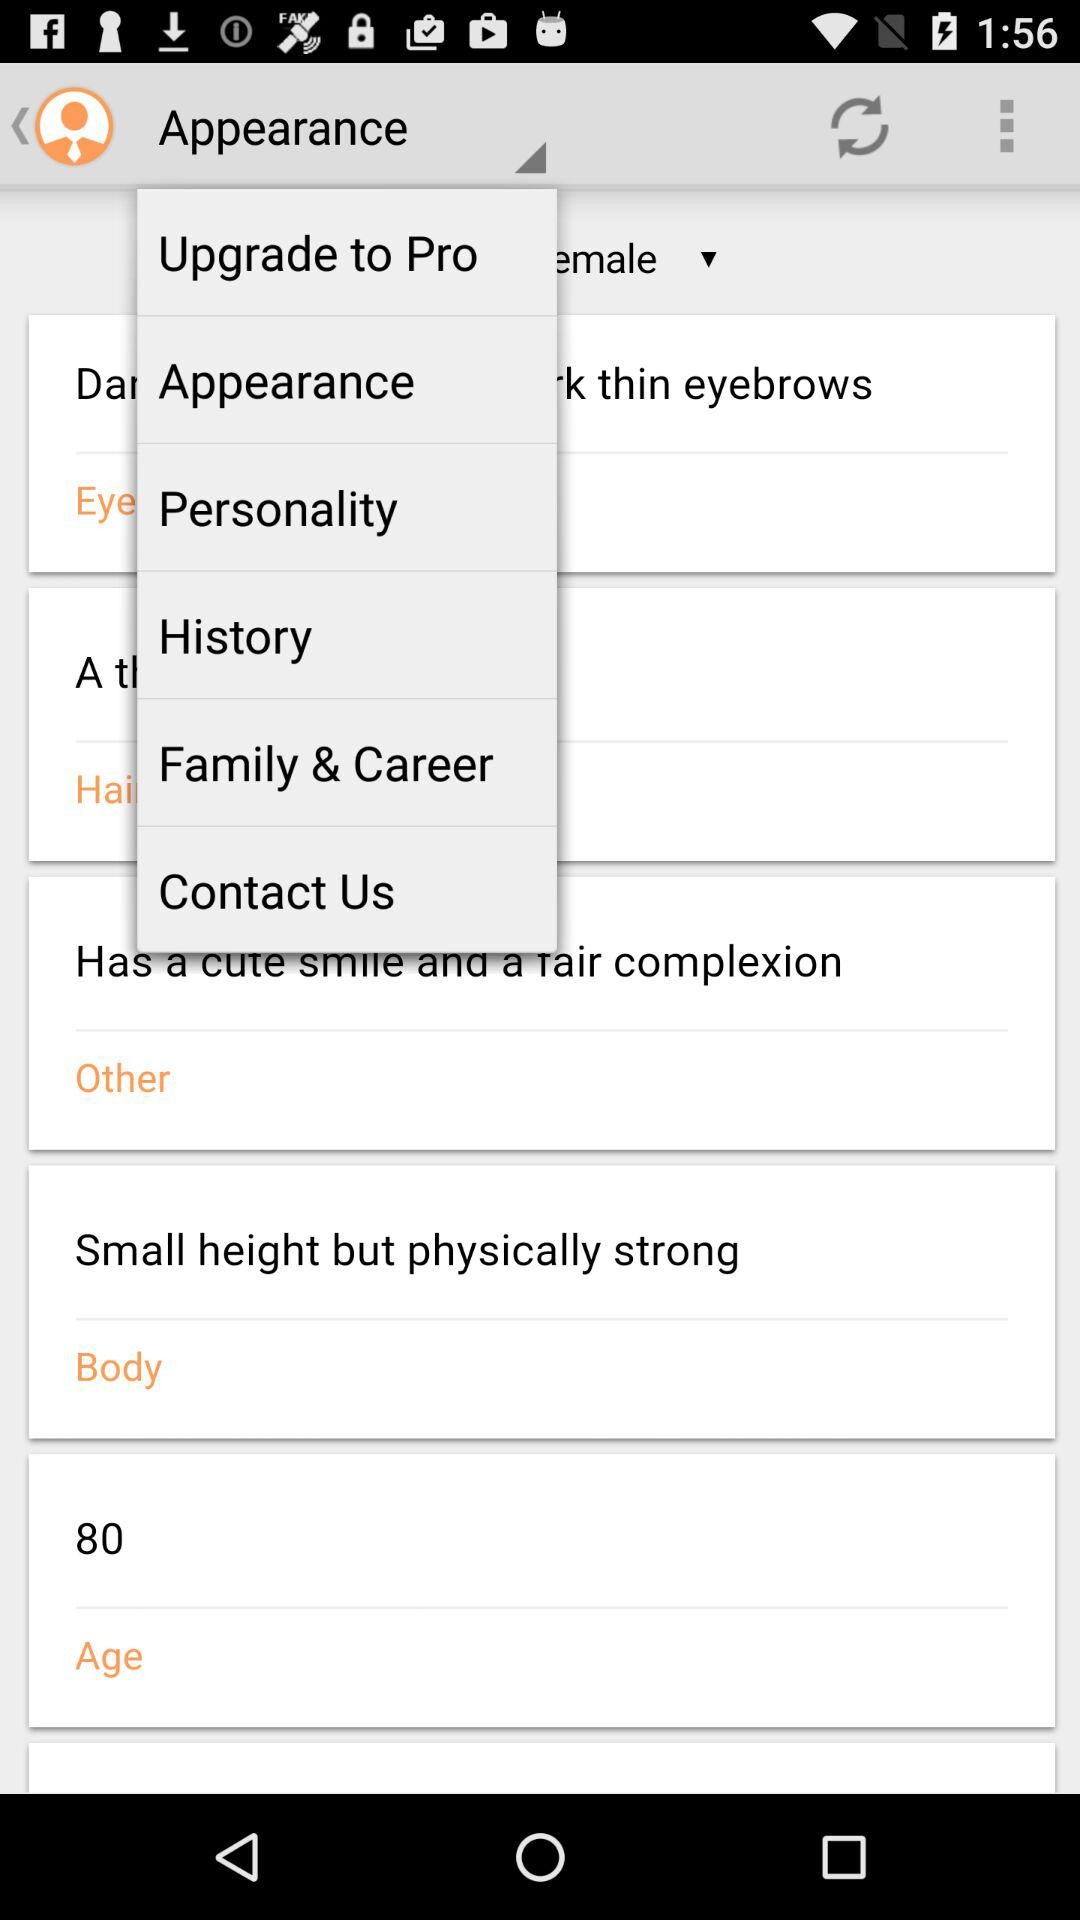What is the given age? The given age is 80. 